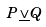<formula> <loc_0><loc_0><loc_500><loc_500>P \underline { \vee } Q</formula> 